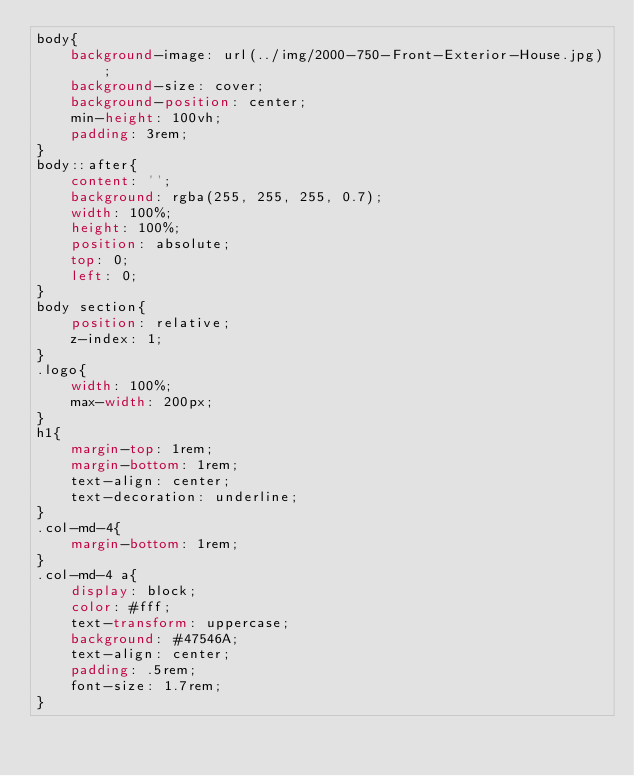Convert code to text. <code><loc_0><loc_0><loc_500><loc_500><_CSS_>body{
    background-image: url(../img/2000-750-Front-Exterior-House.jpg);
    background-size: cover;
    background-position: center;
    min-height: 100vh;
    padding: 3rem;
}
body::after{
    content: '';
    background: rgba(255, 255, 255, 0.7);
    width: 100%;
    height: 100%;
    position: absolute;
    top: 0;
    left: 0;
}
body section{
    position: relative;
    z-index: 1;
}
.logo{
    width: 100%;
    max-width: 200px;
}
h1{
    margin-top: 1rem;
    margin-bottom: 1rem;
    text-align: center;
    text-decoration: underline;
}
.col-md-4{
    margin-bottom: 1rem;
}
.col-md-4 a{
    display: block;
    color: #fff;
    text-transform: uppercase;
    background: #47546A;
    text-align: center;
    padding: .5rem;
    font-size: 1.7rem;
}</code> 